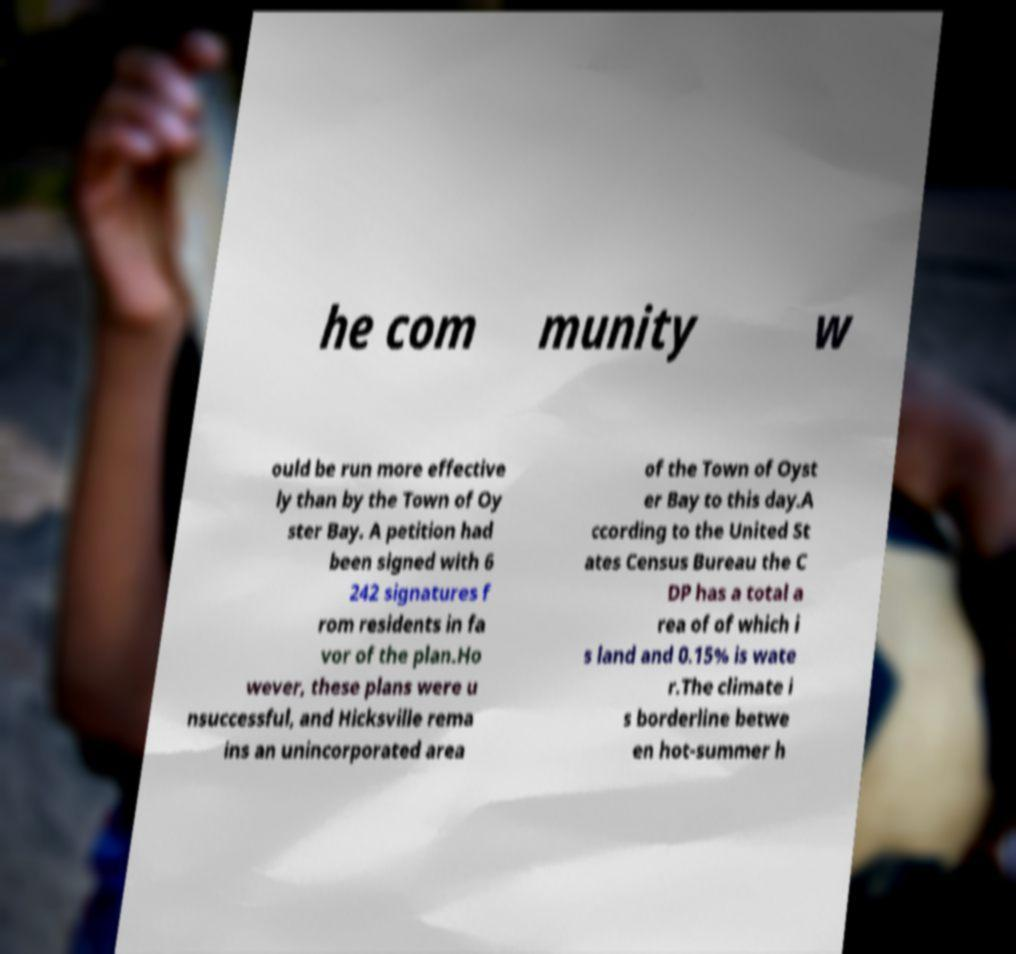Can you read and provide the text displayed in the image?This photo seems to have some interesting text. Can you extract and type it out for me? he com munity w ould be run more effective ly than by the Town of Oy ster Bay. A petition had been signed with 6 242 signatures f rom residents in fa vor of the plan.Ho wever, these plans were u nsuccessful, and Hicksville rema ins an unincorporated area of the Town of Oyst er Bay to this day.A ccording to the United St ates Census Bureau the C DP has a total a rea of of which i s land and 0.15% is wate r.The climate i s borderline betwe en hot-summer h 